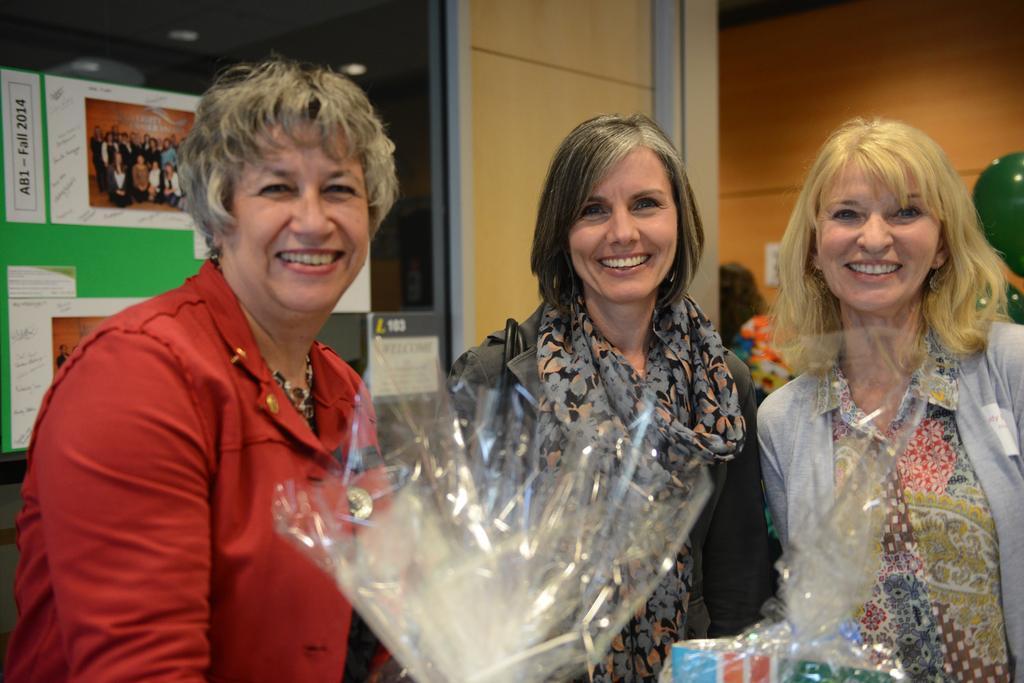Please provide a concise description of this image. In this picture we can see three women smiling. There is some text, numbers, images of a few people and a few things on the boards. We can see the lights and other objects. 